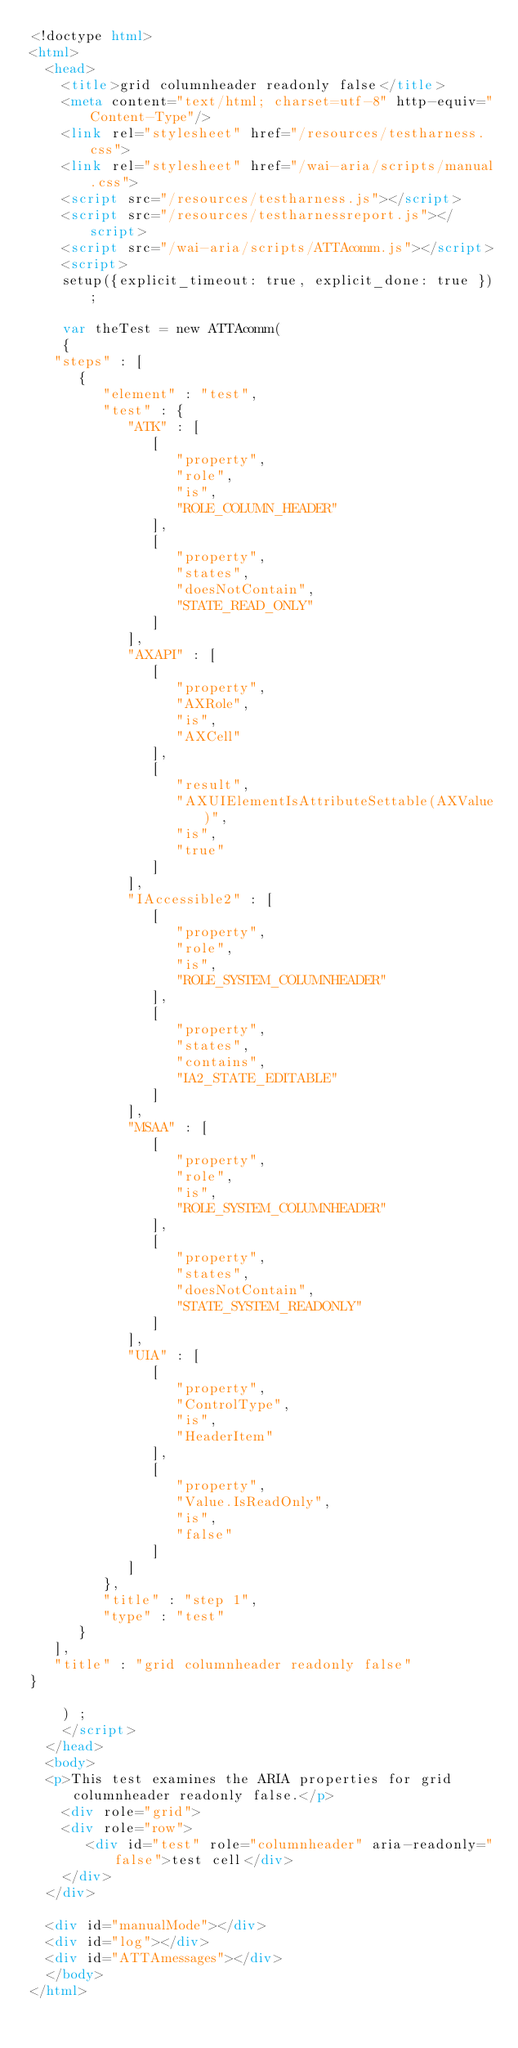<code> <loc_0><loc_0><loc_500><loc_500><_HTML_><!doctype html>
<html>
  <head>
    <title>grid columnheader readonly false</title>
    <meta content="text/html; charset=utf-8" http-equiv="Content-Type"/>
    <link rel="stylesheet" href="/resources/testharness.css">
    <link rel="stylesheet" href="/wai-aria/scripts/manual.css">
    <script src="/resources/testharness.js"></script>
    <script src="/resources/testharnessreport.js"></script>
    <script src="/wai-aria/scripts/ATTAcomm.js"></script>
    <script>
    setup({explicit_timeout: true, explicit_done: true });

    var theTest = new ATTAcomm(
    {
   "steps" : [
      {
         "element" : "test",
         "test" : {
            "ATK" : [
               [
                  "property",
                  "role",
                  "is",
                  "ROLE_COLUMN_HEADER"
               ],
               [
                  "property",
                  "states",
                  "doesNotContain",
                  "STATE_READ_ONLY"
               ]
            ],
            "AXAPI" : [
               [
                  "property",
                  "AXRole",
                  "is",
                  "AXCell"
               ],
               [
                  "result",
                  "AXUIElementIsAttributeSettable(AXValue)",
                  "is",
                  "true"
               ]
            ],
            "IAccessible2" : [
               [
                  "property",
                  "role",
                  "is",
                  "ROLE_SYSTEM_COLUMNHEADER"
               ],
               [
                  "property",
                  "states",
                  "contains",
                  "IA2_STATE_EDITABLE"
               ]
            ],
            "MSAA" : [
               [
                  "property",
                  "role",
                  "is",
                  "ROLE_SYSTEM_COLUMNHEADER"
               ],
               [
                  "property",
                  "states",
                  "doesNotContain",
                  "STATE_SYSTEM_READONLY"
               ]
            ],
            "UIA" : [
               [
                  "property",
                  "ControlType",
                  "is",
                  "HeaderItem"
               ],
               [
                  "property",
                  "Value.IsReadOnly",
                  "is",
                  "false"
               ]
            ]
         },
         "title" : "step 1",
         "type" : "test"
      }
   ],
   "title" : "grid columnheader readonly false"
}

    ) ;
    </script>
  </head>
  <body>
  <p>This test examines the ARIA properties for grid columnheader readonly false.</p>
    <div role="grid">
    <div role="row">
       <div id="test" role="columnheader" aria-readonly="false">test cell</div>
    </div>
  </div>

  <div id="manualMode"></div>
  <div id="log"></div>
  <div id="ATTAmessages"></div>
  </body>
</html>
</code> 